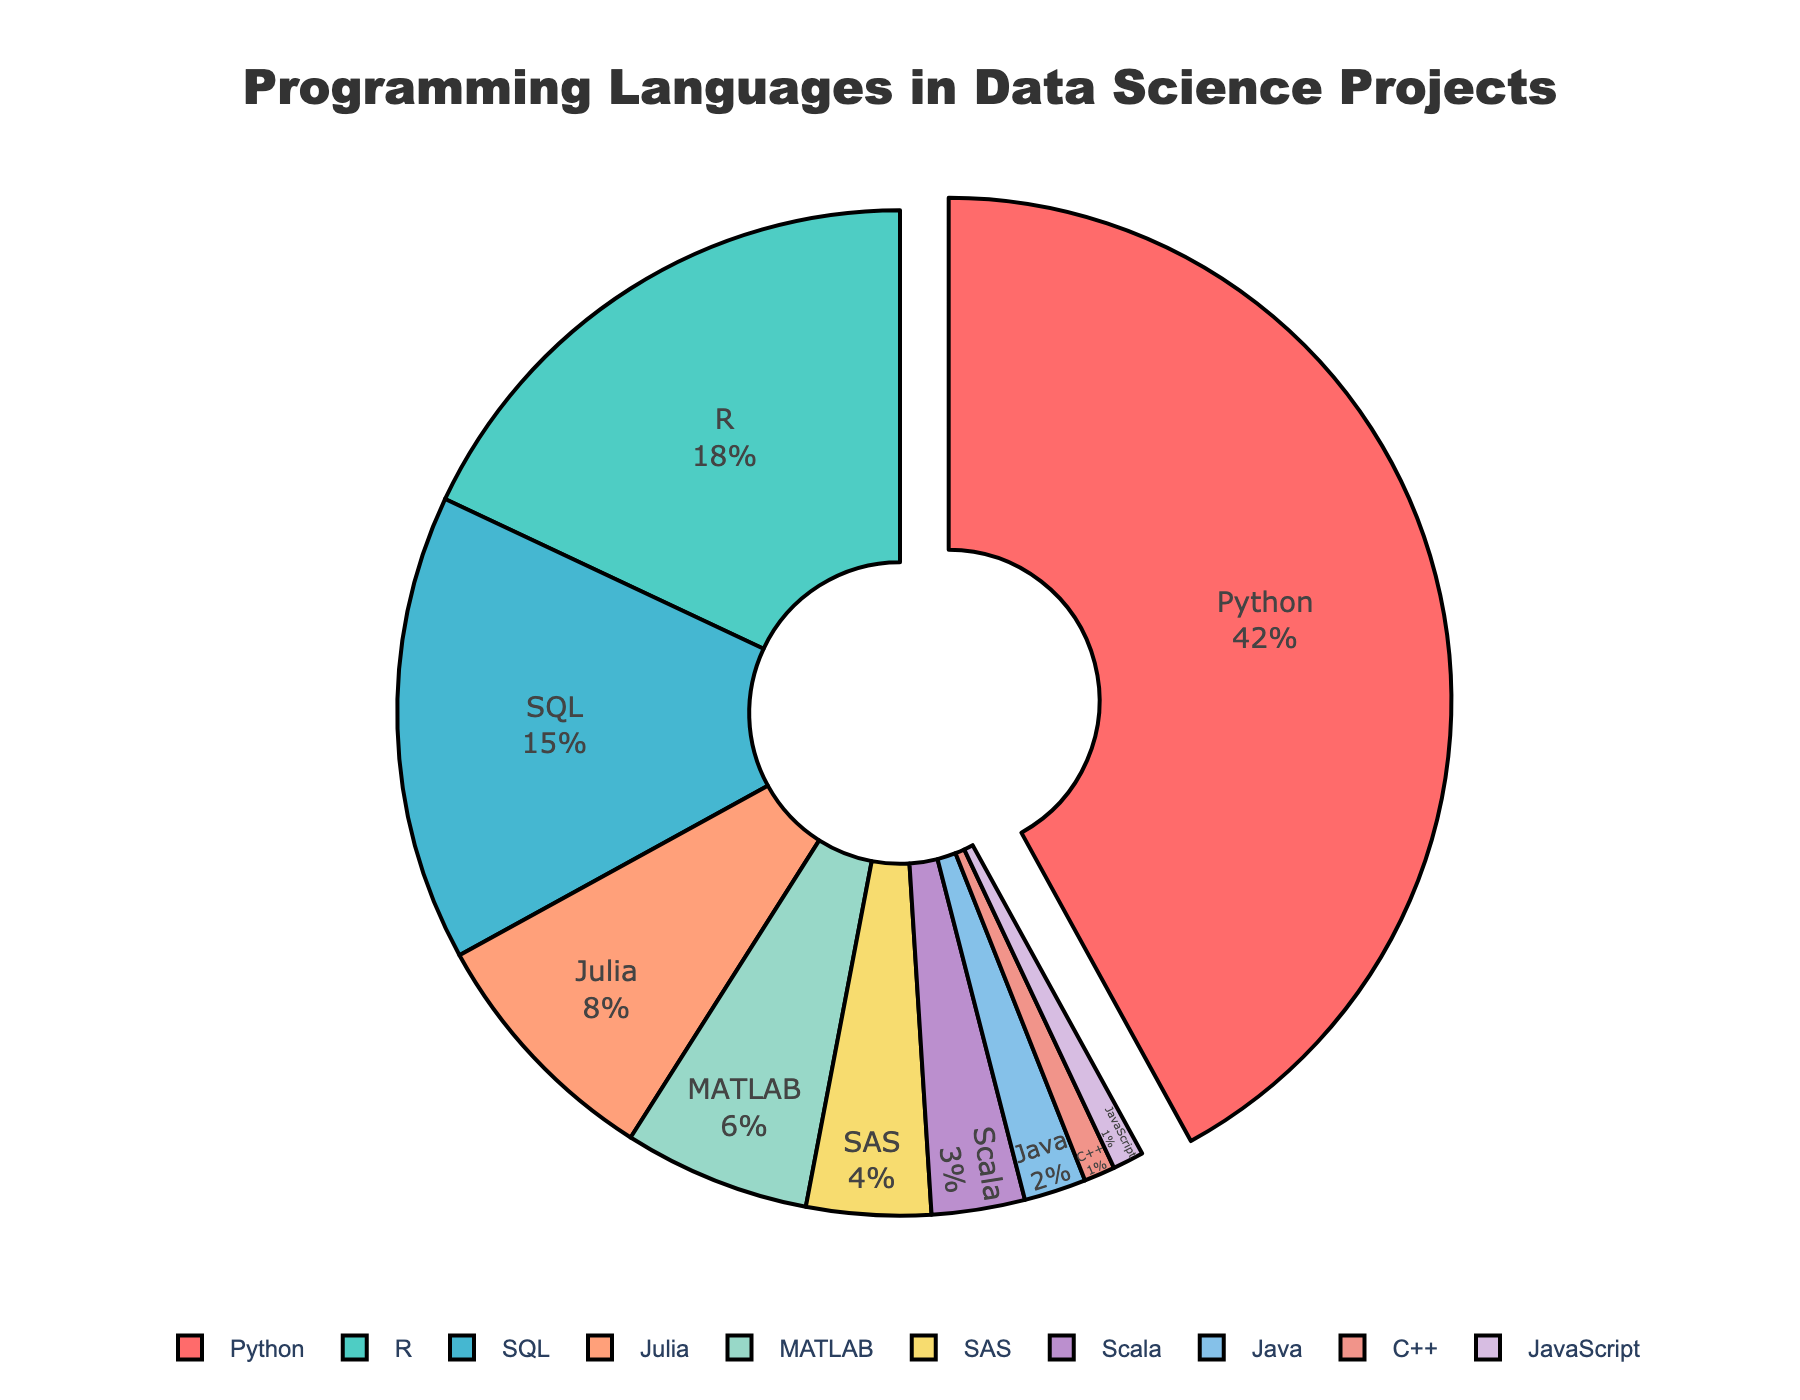What percentage of projects use Python? From the pie chart, identify the slice labeled "Python" and read the associated percentage value.
Answer: 42% Which language is used the least in data science projects? Find the smallest slice in the pie chart and read its label.
Answer: JavaScript and C++ What is the combined percentage of R and SQL usage? Locate both R and SQL slices in the pie chart, then sum their percentages: 18% (R) + 15% (SQL) = 33%.
Answer: 33% How much more popular is Python than Julia? Subtract the percentage of Julia from Python: 42% (Python) - 8% (Julia) = 34%.
Answer: 34% Identify two languages with equal representation and specify their percentage. Find slices with identical percentages and their labels. Both C++ and JavaScript slices each show 1%.
Answer: C++ and JavaScript, 1% Which language has a usage percentage between MATLAB and SAS? Look for the slices corresponding to MATLAB and SAS, then identify the slice with a percentage between them. MATLAB is 6%, SAS is 4%, so the language in between is Julia with 8%.
Answer: Julia Estimate the difference in percentage usage between the most and least popular languages. Identify the largest and smallest percentages in the pie chart: 42% (Python) - 1% (JavaScript and C++) = 41%.
Answer: 41% Arrange the top three languages used in data science projects by their usage percentage. Identify the three largest slices and rank them: 42% (Python), 18% (R), 15% (SQL).
Answer: Python, R, SQL Which color represents the slice for SQL? Match the slice labeled SQL with its color in the pie chart.
Answer: Light blue 